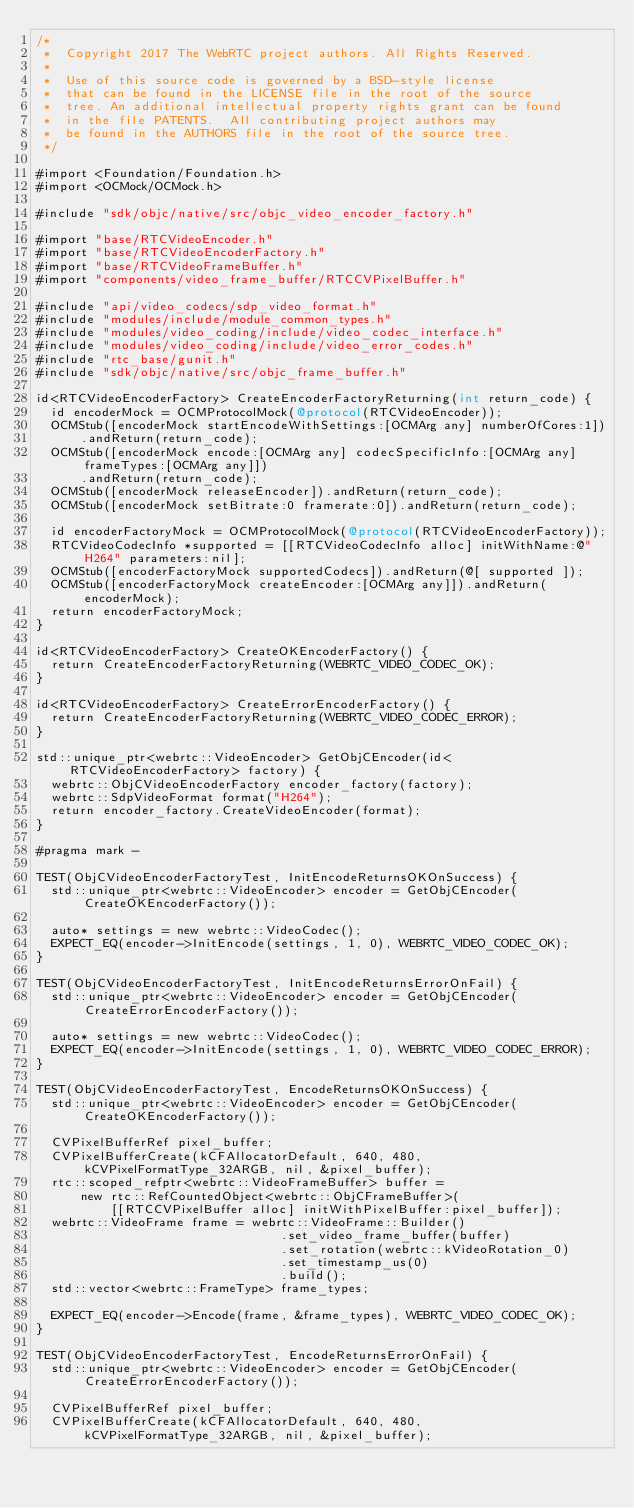<code> <loc_0><loc_0><loc_500><loc_500><_ObjectiveC_>/*
 *  Copyright 2017 The WebRTC project authors. All Rights Reserved.
 *
 *  Use of this source code is governed by a BSD-style license
 *  that can be found in the LICENSE file in the root of the source
 *  tree. An additional intellectual property rights grant can be found
 *  in the file PATENTS.  All contributing project authors may
 *  be found in the AUTHORS file in the root of the source tree.
 */

#import <Foundation/Foundation.h>
#import <OCMock/OCMock.h>

#include "sdk/objc/native/src/objc_video_encoder_factory.h"

#import "base/RTCVideoEncoder.h"
#import "base/RTCVideoEncoderFactory.h"
#import "base/RTCVideoFrameBuffer.h"
#import "components/video_frame_buffer/RTCCVPixelBuffer.h"

#include "api/video_codecs/sdp_video_format.h"
#include "modules/include/module_common_types.h"
#include "modules/video_coding/include/video_codec_interface.h"
#include "modules/video_coding/include/video_error_codes.h"
#include "rtc_base/gunit.h"
#include "sdk/objc/native/src/objc_frame_buffer.h"

id<RTCVideoEncoderFactory> CreateEncoderFactoryReturning(int return_code) {
  id encoderMock = OCMProtocolMock(@protocol(RTCVideoEncoder));
  OCMStub([encoderMock startEncodeWithSettings:[OCMArg any] numberOfCores:1])
      .andReturn(return_code);
  OCMStub([encoderMock encode:[OCMArg any] codecSpecificInfo:[OCMArg any] frameTypes:[OCMArg any]])
      .andReturn(return_code);
  OCMStub([encoderMock releaseEncoder]).andReturn(return_code);
  OCMStub([encoderMock setBitrate:0 framerate:0]).andReturn(return_code);

  id encoderFactoryMock = OCMProtocolMock(@protocol(RTCVideoEncoderFactory));
  RTCVideoCodecInfo *supported = [[RTCVideoCodecInfo alloc] initWithName:@"H264" parameters:nil];
  OCMStub([encoderFactoryMock supportedCodecs]).andReturn(@[ supported ]);
  OCMStub([encoderFactoryMock createEncoder:[OCMArg any]]).andReturn(encoderMock);
  return encoderFactoryMock;
}

id<RTCVideoEncoderFactory> CreateOKEncoderFactory() {
  return CreateEncoderFactoryReturning(WEBRTC_VIDEO_CODEC_OK);
}

id<RTCVideoEncoderFactory> CreateErrorEncoderFactory() {
  return CreateEncoderFactoryReturning(WEBRTC_VIDEO_CODEC_ERROR);
}

std::unique_ptr<webrtc::VideoEncoder> GetObjCEncoder(id<RTCVideoEncoderFactory> factory) {
  webrtc::ObjCVideoEncoderFactory encoder_factory(factory);
  webrtc::SdpVideoFormat format("H264");
  return encoder_factory.CreateVideoEncoder(format);
}

#pragma mark -

TEST(ObjCVideoEncoderFactoryTest, InitEncodeReturnsOKOnSuccess) {
  std::unique_ptr<webrtc::VideoEncoder> encoder = GetObjCEncoder(CreateOKEncoderFactory());

  auto* settings = new webrtc::VideoCodec();
  EXPECT_EQ(encoder->InitEncode(settings, 1, 0), WEBRTC_VIDEO_CODEC_OK);
}

TEST(ObjCVideoEncoderFactoryTest, InitEncodeReturnsErrorOnFail) {
  std::unique_ptr<webrtc::VideoEncoder> encoder = GetObjCEncoder(CreateErrorEncoderFactory());

  auto* settings = new webrtc::VideoCodec();
  EXPECT_EQ(encoder->InitEncode(settings, 1, 0), WEBRTC_VIDEO_CODEC_ERROR);
}

TEST(ObjCVideoEncoderFactoryTest, EncodeReturnsOKOnSuccess) {
  std::unique_ptr<webrtc::VideoEncoder> encoder = GetObjCEncoder(CreateOKEncoderFactory());

  CVPixelBufferRef pixel_buffer;
  CVPixelBufferCreate(kCFAllocatorDefault, 640, 480, kCVPixelFormatType_32ARGB, nil, &pixel_buffer);
  rtc::scoped_refptr<webrtc::VideoFrameBuffer> buffer =
      new rtc::RefCountedObject<webrtc::ObjCFrameBuffer>(
          [[RTCCVPixelBuffer alloc] initWithPixelBuffer:pixel_buffer]);
  webrtc::VideoFrame frame = webrtc::VideoFrame::Builder()
                                 .set_video_frame_buffer(buffer)
                                 .set_rotation(webrtc::kVideoRotation_0)
                                 .set_timestamp_us(0)
                                 .build();
  std::vector<webrtc::FrameType> frame_types;

  EXPECT_EQ(encoder->Encode(frame, &frame_types), WEBRTC_VIDEO_CODEC_OK);
}

TEST(ObjCVideoEncoderFactoryTest, EncodeReturnsErrorOnFail) {
  std::unique_ptr<webrtc::VideoEncoder> encoder = GetObjCEncoder(CreateErrorEncoderFactory());

  CVPixelBufferRef pixel_buffer;
  CVPixelBufferCreate(kCFAllocatorDefault, 640, 480, kCVPixelFormatType_32ARGB, nil, &pixel_buffer);</code> 